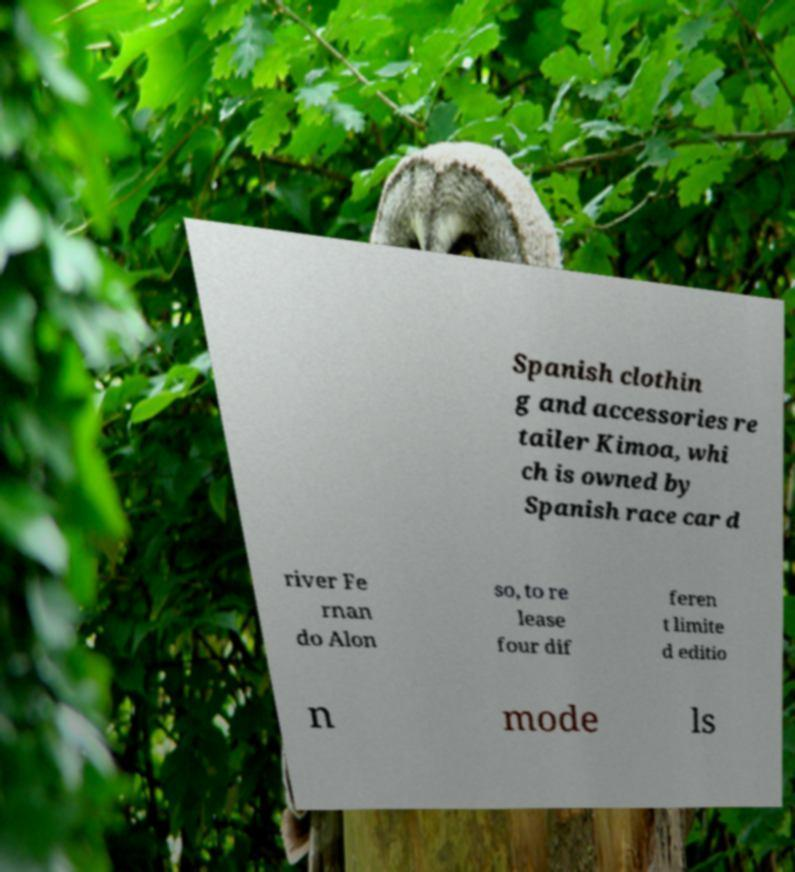Could you extract and type out the text from this image? Spanish clothin g and accessories re tailer Kimoa, whi ch is owned by Spanish race car d river Fe rnan do Alon so, to re lease four dif feren t limite d editio n mode ls 